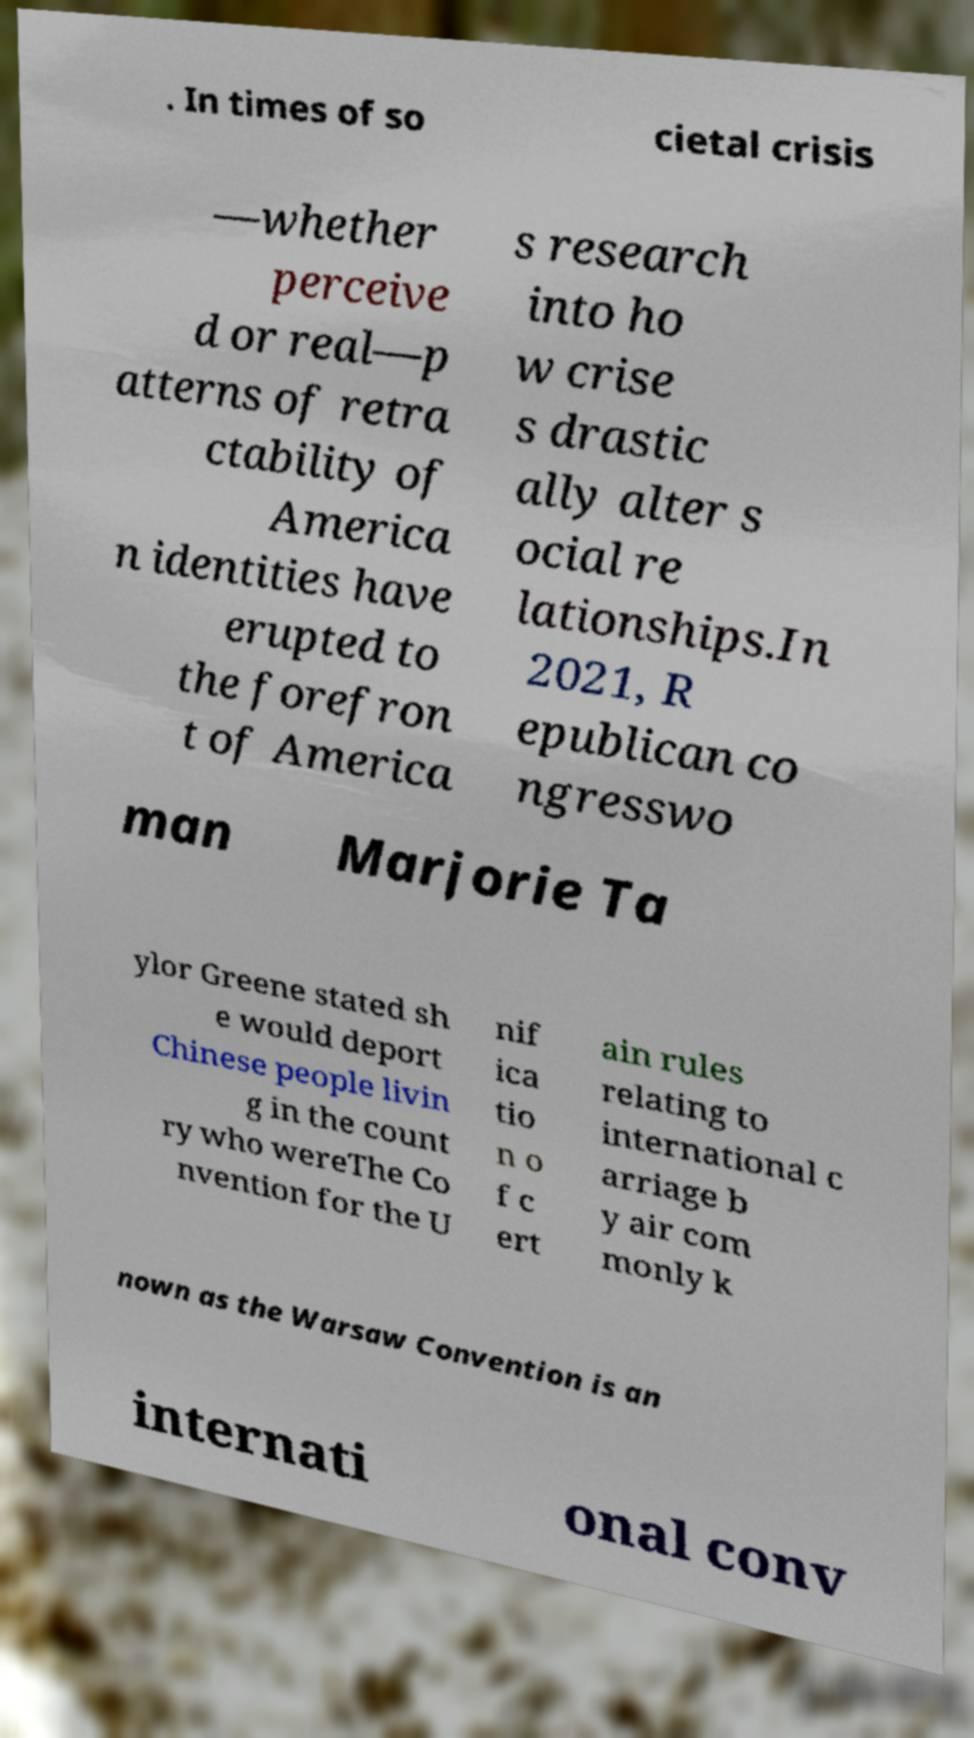For documentation purposes, I need the text within this image transcribed. Could you provide that? . In times of so cietal crisis —whether perceive d or real—p atterns of retra ctability of America n identities have erupted to the forefron t of America s research into ho w crise s drastic ally alter s ocial re lationships.In 2021, R epublican co ngresswo man Marjorie Ta ylor Greene stated sh e would deport Chinese people livin g in the count ry who wereThe Co nvention for the U nif ica tio n o f c ert ain rules relating to international c arriage b y air com monly k nown as the Warsaw Convention is an internati onal conv 